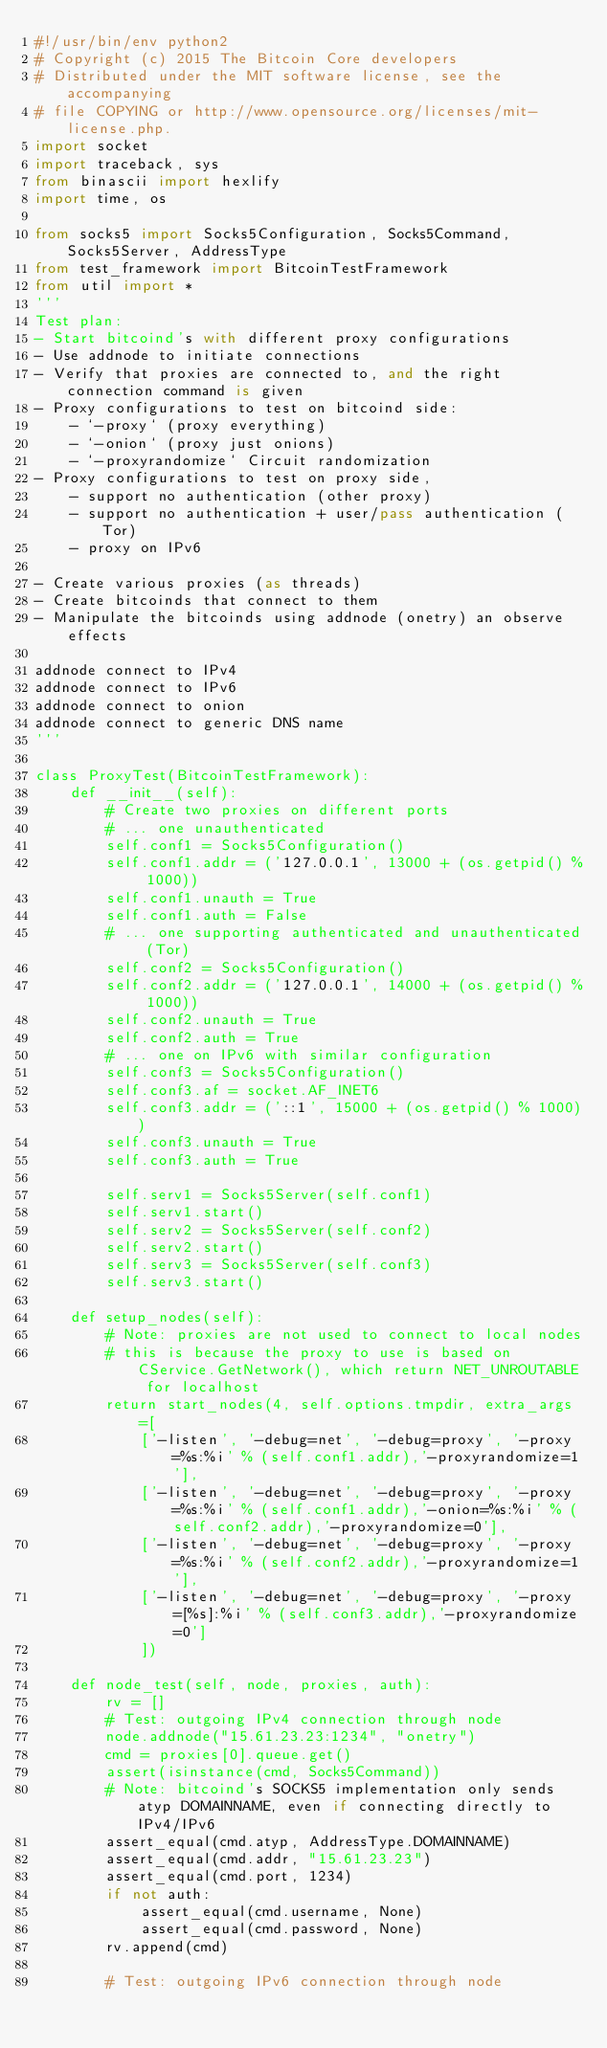Convert code to text. <code><loc_0><loc_0><loc_500><loc_500><_Python_>#!/usr/bin/env python2
# Copyright (c) 2015 The Bitcoin Core developers
# Distributed under the MIT software license, see the accompanying
# file COPYING or http://www.opensource.org/licenses/mit-license.php.
import socket
import traceback, sys
from binascii import hexlify
import time, os

from socks5 import Socks5Configuration, Socks5Command, Socks5Server, AddressType
from test_framework import BitcoinTestFramework
from util import *
'''
Test plan:
- Start bitcoind's with different proxy configurations
- Use addnode to initiate connections
- Verify that proxies are connected to, and the right connection command is given
- Proxy configurations to test on bitcoind side:
    - `-proxy` (proxy everything)
    - `-onion` (proxy just onions)
    - `-proxyrandomize` Circuit randomization
- Proxy configurations to test on proxy side,
    - support no authentication (other proxy)
    - support no authentication + user/pass authentication (Tor)
    - proxy on IPv6

- Create various proxies (as threads)
- Create bitcoinds that connect to them
- Manipulate the bitcoinds using addnode (onetry) an observe effects

addnode connect to IPv4
addnode connect to IPv6
addnode connect to onion
addnode connect to generic DNS name
'''

class ProxyTest(BitcoinTestFramework):
    def __init__(self):
        # Create two proxies on different ports
        # ... one unauthenticated
        self.conf1 = Socks5Configuration()
        self.conf1.addr = ('127.0.0.1', 13000 + (os.getpid() % 1000))
        self.conf1.unauth = True
        self.conf1.auth = False
        # ... one supporting authenticated and unauthenticated (Tor)
        self.conf2 = Socks5Configuration()
        self.conf2.addr = ('127.0.0.1', 14000 + (os.getpid() % 1000))
        self.conf2.unauth = True
        self.conf2.auth = True
        # ... one on IPv6 with similar configuration
        self.conf3 = Socks5Configuration()
        self.conf3.af = socket.AF_INET6
        self.conf3.addr = ('::1', 15000 + (os.getpid() % 1000))
        self.conf3.unauth = True
        self.conf3.auth = True

        self.serv1 = Socks5Server(self.conf1)
        self.serv1.start()
        self.serv2 = Socks5Server(self.conf2)
        self.serv2.start()
        self.serv3 = Socks5Server(self.conf3)
        self.serv3.start()

    def setup_nodes(self):
        # Note: proxies are not used to connect to local nodes
        # this is because the proxy to use is based on CService.GetNetwork(), which return NET_UNROUTABLE for localhost
        return start_nodes(4, self.options.tmpdir, extra_args=[
            ['-listen', '-debug=net', '-debug=proxy', '-proxy=%s:%i' % (self.conf1.addr),'-proxyrandomize=1'],
            ['-listen', '-debug=net', '-debug=proxy', '-proxy=%s:%i' % (self.conf1.addr),'-onion=%s:%i' % (self.conf2.addr),'-proxyrandomize=0'],
            ['-listen', '-debug=net', '-debug=proxy', '-proxy=%s:%i' % (self.conf2.addr),'-proxyrandomize=1'],
            ['-listen', '-debug=net', '-debug=proxy', '-proxy=[%s]:%i' % (self.conf3.addr),'-proxyrandomize=0']
            ])

    def node_test(self, node, proxies, auth):
        rv = []
        # Test: outgoing IPv4 connection through node
        node.addnode("15.61.23.23:1234", "onetry")
        cmd = proxies[0].queue.get()
        assert(isinstance(cmd, Socks5Command))
        # Note: bitcoind's SOCKS5 implementation only sends atyp DOMAINNAME, even if connecting directly to IPv4/IPv6
        assert_equal(cmd.atyp, AddressType.DOMAINNAME)
        assert_equal(cmd.addr, "15.61.23.23")
        assert_equal(cmd.port, 1234)
        if not auth:
            assert_equal(cmd.username, None)
            assert_equal(cmd.password, None)
        rv.append(cmd)

        # Test: outgoing IPv6 connection through node</code> 